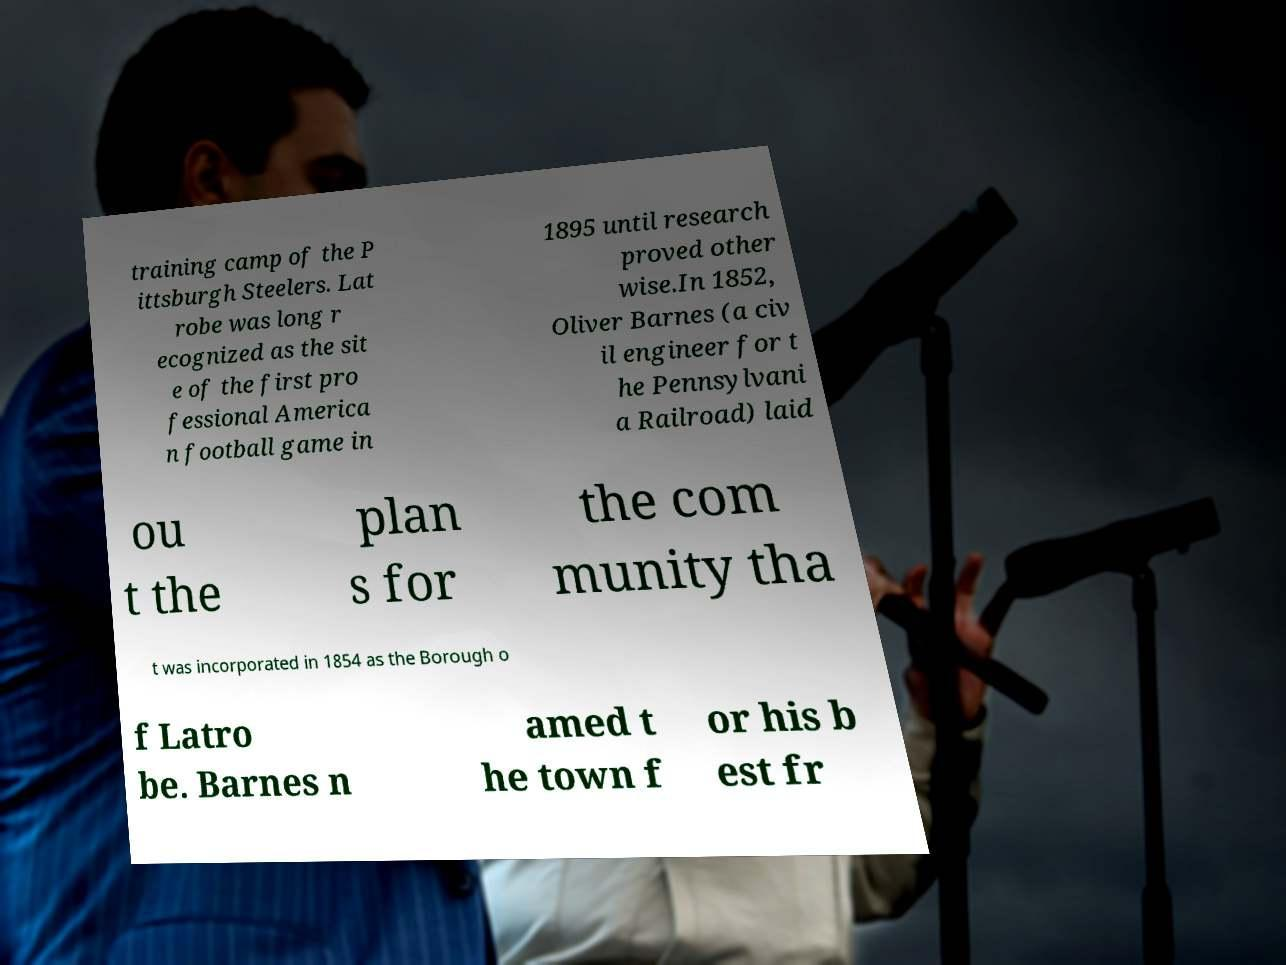For documentation purposes, I need the text within this image transcribed. Could you provide that? training camp of the P ittsburgh Steelers. Lat robe was long r ecognized as the sit e of the first pro fessional America n football game in 1895 until research proved other wise.In 1852, Oliver Barnes (a civ il engineer for t he Pennsylvani a Railroad) laid ou t the plan s for the com munity tha t was incorporated in 1854 as the Borough o f Latro be. Barnes n amed t he town f or his b est fr 